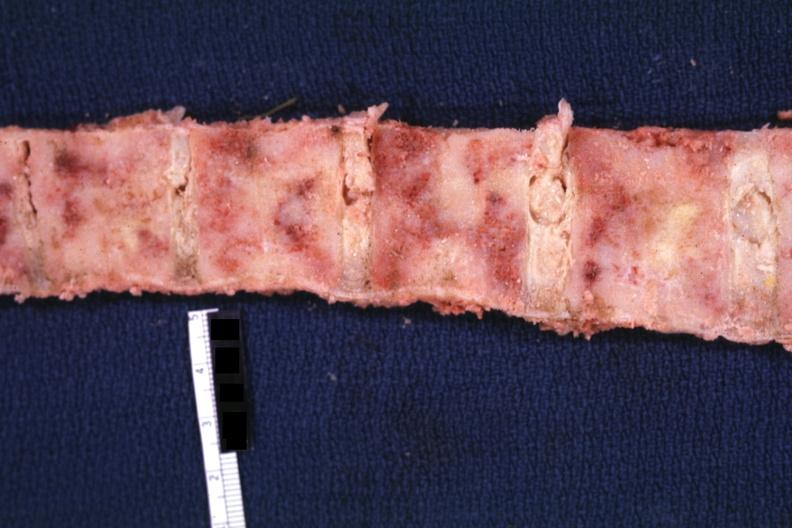does this image show marrow filled with obvious tumor?
Answer the question using a single word or phrase. Yes 